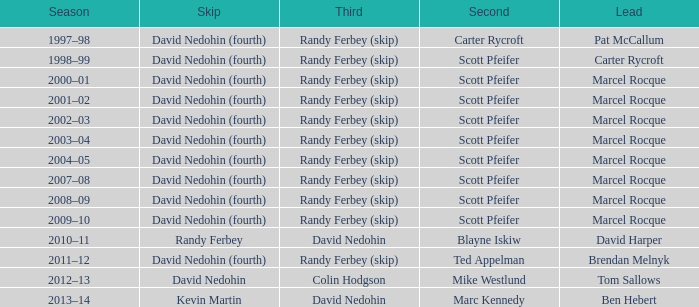Which lead features a third of randy ferbey (skip), a second of scott pfeifer, and a 2009-10 season? Marcel Rocque. Give me the full table as a dictionary. {'header': ['Season', 'Skip', 'Third', 'Second', 'Lead'], 'rows': [['1997–98', 'David Nedohin (fourth)', 'Randy Ferbey (skip)', 'Carter Rycroft', 'Pat McCallum'], ['1998–99', 'David Nedohin (fourth)', 'Randy Ferbey (skip)', 'Scott Pfeifer', 'Carter Rycroft'], ['2000–01', 'David Nedohin (fourth)', 'Randy Ferbey (skip)', 'Scott Pfeifer', 'Marcel Rocque'], ['2001–02', 'David Nedohin (fourth)', 'Randy Ferbey (skip)', 'Scott Pfeifer', 'Marcel Rocque'], ['2002–03', 'David Nedohin (fourth)', 'Randy Ferbey (skip)', 'Scott Pfeifer', 'Marcel Rocque'], ['2003–04', 'David Nedohin (fourth)', 'Randy Ferbey (skip)', 'Scott Pfeifer', 'Marcel Rocque'], ['2004–05', 'David Nedohin (fourth)', 'Randy Ferbey (skip)', 'Scott Pfeifer', 'Marcel Rocque'], ['2007–08', 'David Nedohin (fourth)', 'Randy Ferbey (skip)', 'Scott Pfeifer', 'Marcel Rocque'], ['2008–09', 'David Nedohin (fourth)', 'Randy Ferbey (skip)', 'Scott Pfeifer', 'Marcel Rocque'], ['2009–10', 'David Nedohin (fourth)', 'Randy Ferbey (skip)', 'Scott Pfeifer', 'Marcel Rocque'], ['2010–11', 'Randy Ferbey', 'David Nedohin', 'Blayne Iskiw', 'David Harper'], ['2011–12', 'David Nedohin (fourth)', 'Randy Ferbey (skip)', 'Ted Appelman', 'Brendan Melnyk'], ['2012–13', 'David Nedohin', 'Colin Hodgson', 'Mike Westlund', 'Tom Sallows'], ['2013–14', 'Kevin Martin', 'David Nedohin', 'Marc Kennedy', 'Ben Hebert']]} 